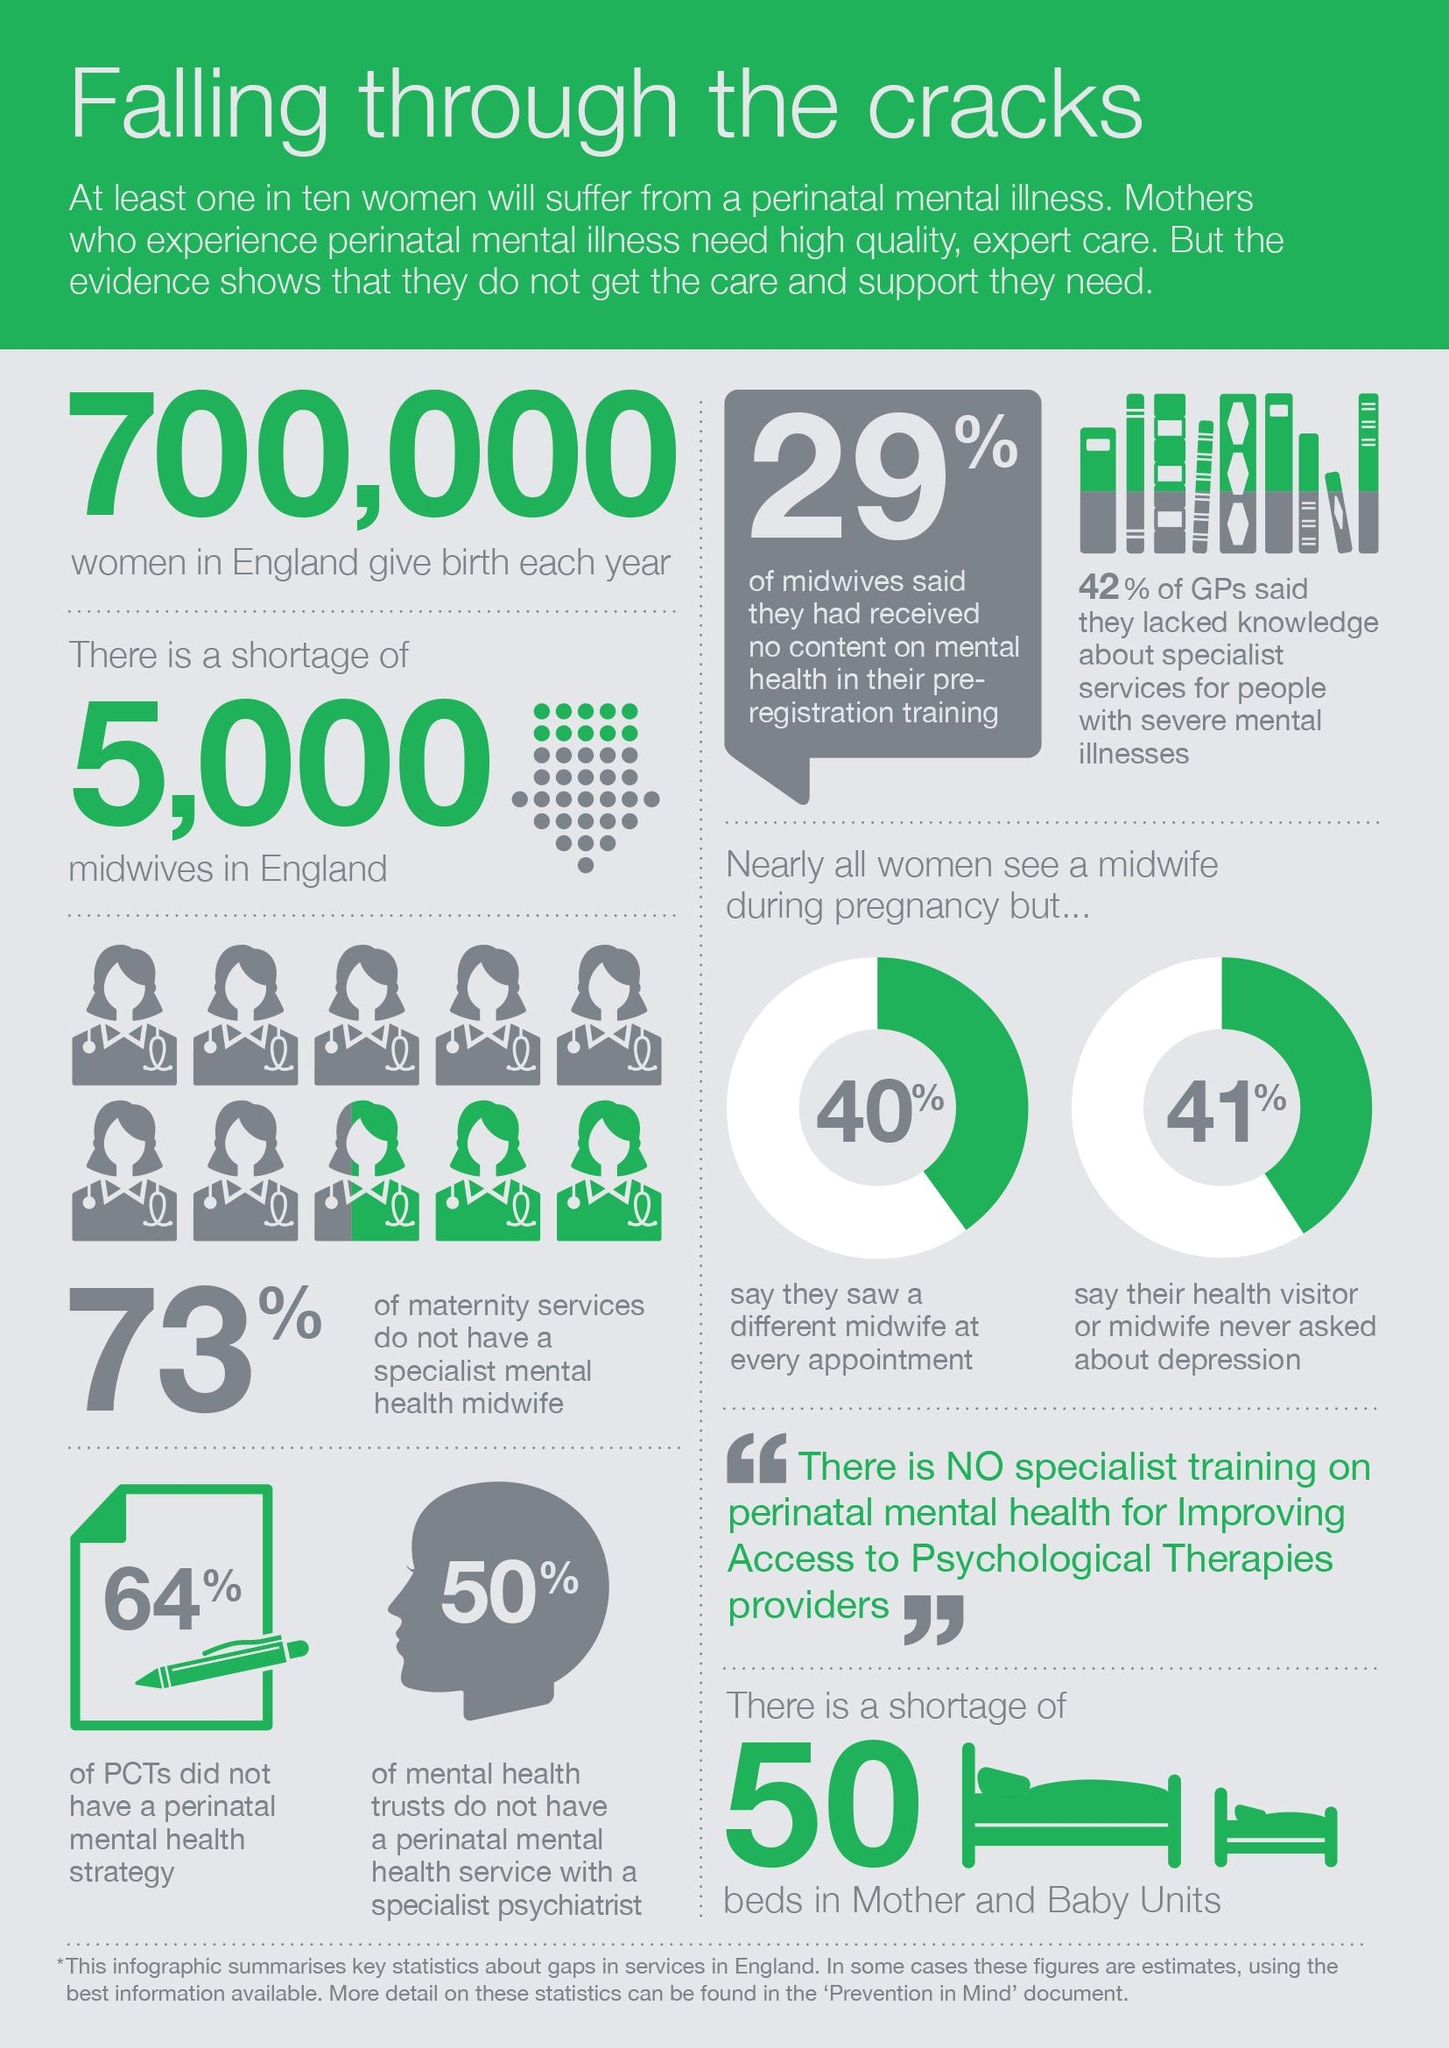Draw attention to some important aspects in this diagram. According to available data, half of mental health trusts in the United Kingdom have a perinatal mental health service with a specialist psychiatrist. According to the information provided, 36% of Perinatal Community Teams (PCTs) have a perinatal mental health strategy in place. According to the data, only 27% of maternity services have a specialist mental health midwife, highlighting the need for increased access to mental health services for pregnant women. 